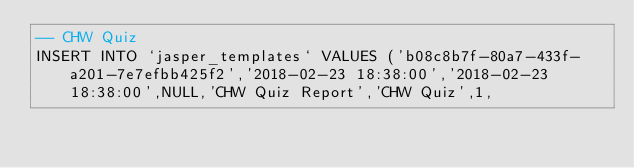Convert code to text. <code><loc_0><loc_0><loc_500><loc_500><_SQL_>-- CHW Quiz
INSERT INTO `jasper_templates` VALUES ('b08c8b7f-80a7-433f-a201-7e7efbb425f2','2018-02-23 18:38:00','2018-02-23 18:38:00',NULL,'CHW Quiz Report','CHW Quiz',1,</code> 